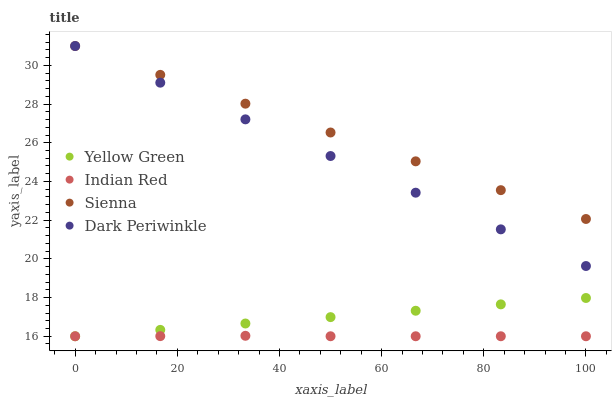Does Indian Red have the minimum area under the curve?
Answer yes or no. Yes. Does Sienna have the maximum area under the curve?
Answer yes or no. Yes. Does Yellow Green have the minimum area under the curve?
Answer yes or no. No. Does Yellow Green have the maximum area under the curve?
Answer yes or no. No. Is Yellow Green the smoothest?
Answer yes or no. Yes. Is Indian Red the roughest?
Answer yes or no. Yes. Is Indian Red the smoothest?
Answer yes or no. No. Is Yellow Green the roughest?
Answer yes or no. No. Does Yellow Green have the lowest value?
Answer yes or no. Yes. Does Dark Periwinkle have the lowest value?
Answer yes or no. No. Does Dark Periwinkle have the highest value?
Answer yes or no. Yes. Does Yellow Green have the highest value?
Answer yes or no. No. Is Yellow Green less than Dark Periwinkle?
Answer yes or no. Yes. Is Dark Periwinkle greater than Indian Red?
Answer yes or no. Yes. Does Dark Periwinkle intersect Sienna?
Answer yes or no. Yes. Is Dark Periwinkle less than Sienna?
Answer yes or no. No. Is Dark Periwinkle greater than Sienna?
Answer yes or no. No. Does Yellow Green intersect Dark Periwinkle?
Answer yes or no. No. 